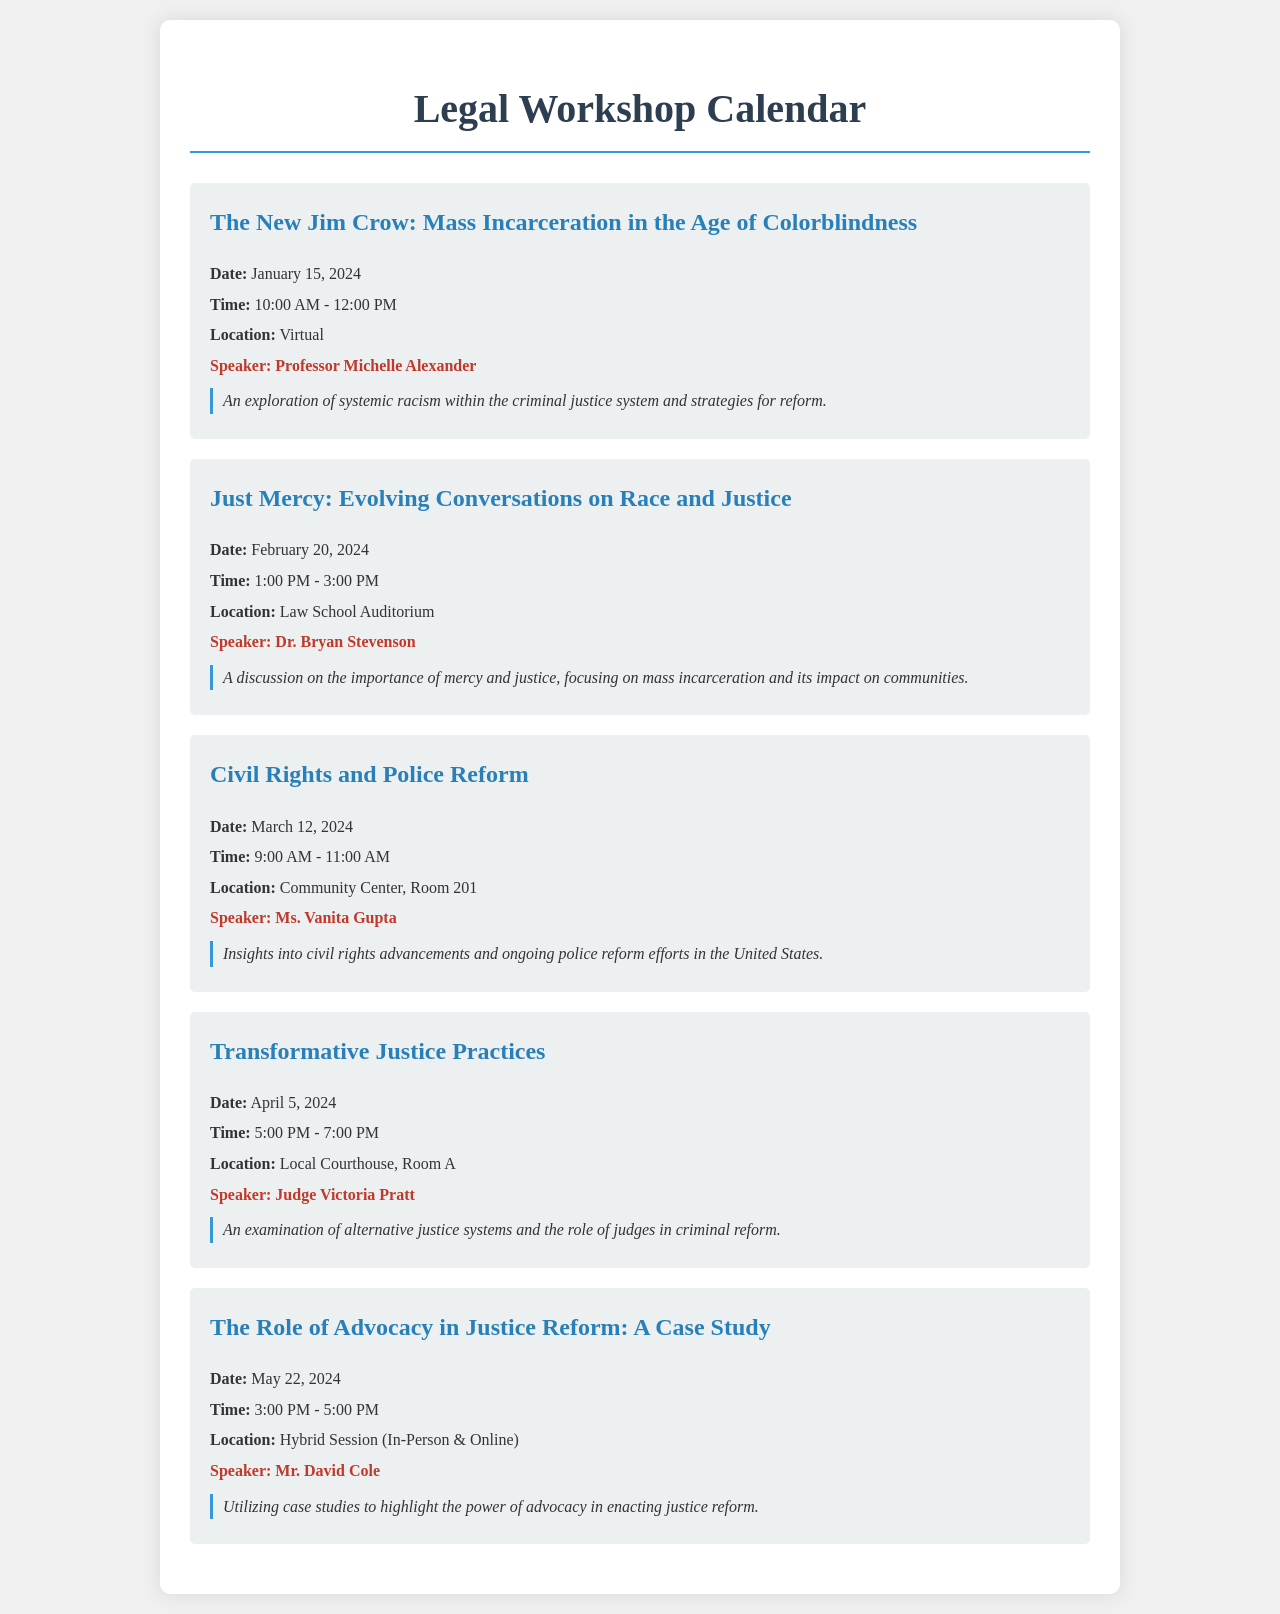What is the date of the workshop on mass incarceration? The date for the workshop titled "The New Jim Crow: Mass Incarceration in the Age of Colorblindness" is January 15, 2024.
Answer: January 15, 2024 Who is the speaker for the workshop on race and justice? The speaker for the workshop titled "Just Mercy: Evolving Conversations on Race and Justice" is Dr. Bryan Stevenson.
Answer: Dr. Bryan Stevenson What is the location of the civil rights workshop? The workshop titled "Civil Rights and Police Reform" will be held at the Community Center, Room 201.
Answer: Community Center, Room 201 How many workshops are scheduled in total? The document lists a total of five workshops.
Answer: Five What is the time for the workshop on transformative justice? The workshop titled "Transformative Justice Practices" is scheduled from 5:00 PM to 7:00 PM.
Answer: 5:00 PM - 7:00 PM What is the main topic of the workshop led by Judge Victoria Pratt? The workshop titled "Transformative Justice Practices" focuses on alternative justice systems.
Answer: Alternative justice systems In what format is the last workshop offered? The last workshop titled "The Role of Advocacy in Justice Reform: A Case Study" is offered as a hybrid session (in-person and online).
Answer: Hybrid Session (In-Person & Online) What is the main theme of the workshop with Professor Michelle Alexander? The theme of the workshop titled "The New Jim Crow" is systemic racism within the criminal justice system.
Answer: Systemic racism within the criminal justice system 